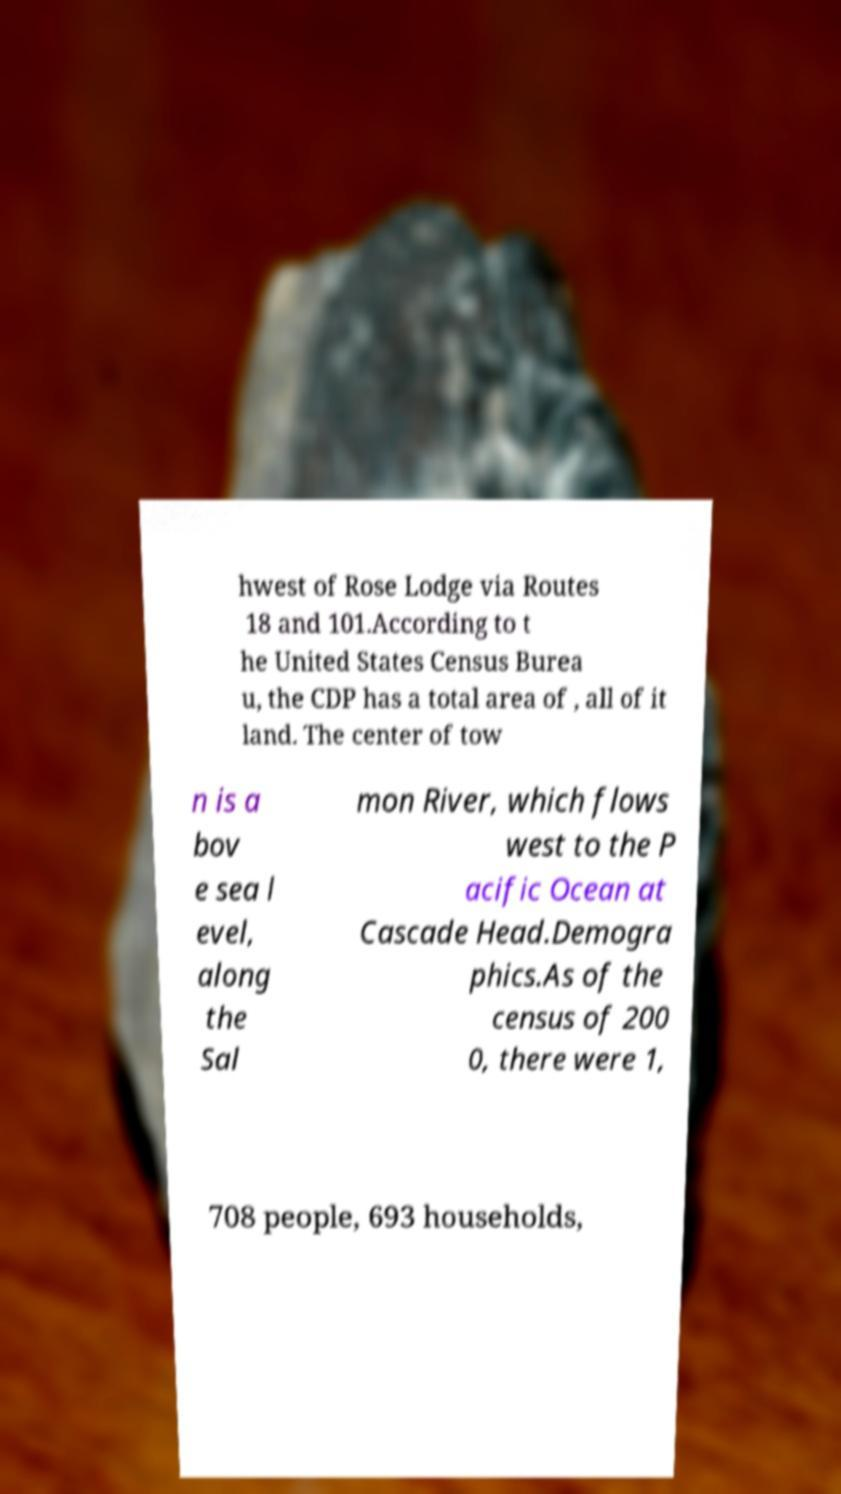For documentation purposes, I need the text within this image transcribed. Could you provide that? hwest of Rose Lodge via Routes 18 and 101.According to t he United States Census Burea u, the CDP has a total area of , all of it land. The center of tow n is a bov e sea l evel, along the Sal mon River, which flows west to the P acific Ocean at Cascade Head.Demogra phics.As of the census of 200 0, there were 1, 708 people, 693 households, 